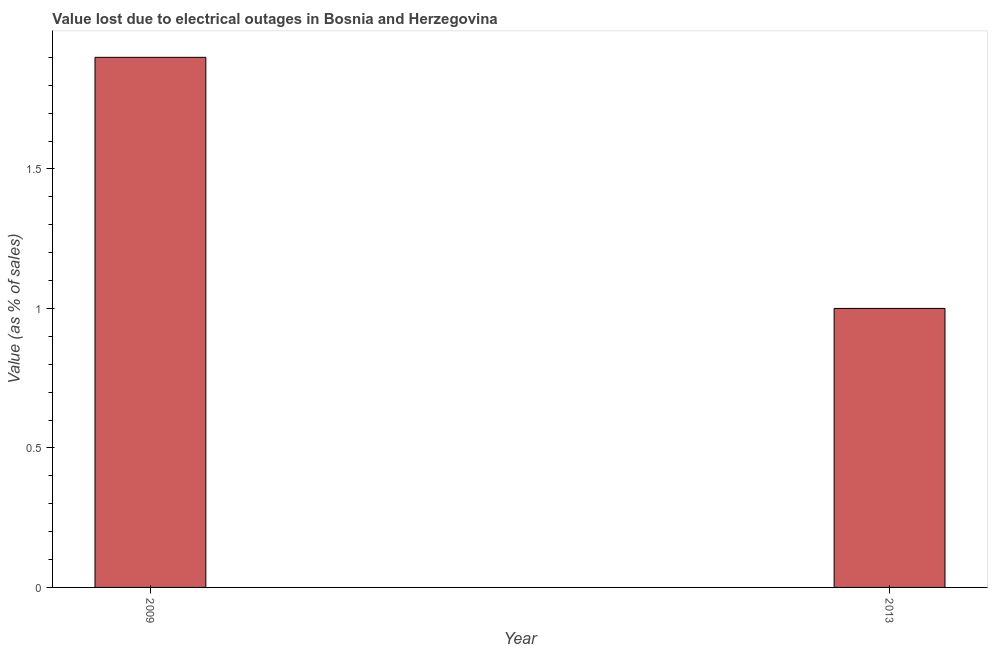Does the graph contain grids?
Offer a very short reply. No. What is the title of the graph?
Offer a terse response. Value lost due to electrical outages in Bosnia and Herzegovina. What is the label or title of the X-axis?
Provide a short and direct response. Year. What is the label or title of the Y-axis?
Your answer should be compact. Value (as % of sales). What is the value lost due to electrical outages in 2013?
Your answer should be very brief. 1. Across all years, what is the minimum value lost due to electrical outages?
Ensure brevity in your answer.  1. In which year was the value lost due to electrical outages maximum?
Your answer should be very brief. 2009. In which year was the value lost due to electrical outages minimum?
Offer a terse response. 2013. What is the average value lost due to electrical outages per year?
Offer a terse response. 1.45. What is the median value lost due to electrical outages?
Keep it short and to the point. 1.45. What is the ratio of the value lost due to electrical outages in 2009 to that in 2013?
Your response must be concise. 1.9. Is the value lost due to electrical outages in 2009 less than that in 2013?
Provide a short and direct response. No. In how many years, is the value lost due to electrical outages greater than the average value lost due to electrical outages taken over all years?
Give a very brief answer. 1. How many bars are there?
Provide a succinct answer. 2. What is the difference between two consecutive major ticks on the Y-axis?
Ensure brevity in your answer.  0.5. What is the Value (as % of sales) in 2009?
Ensure brevity in your answer.  1.9. What is the Value (as % of sales) of 2013?
Your answer should be very brief. 1. 